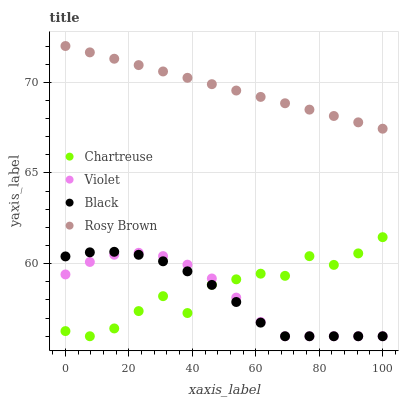Does Black have the minimum area under the curve?
Answer yes or no. Yes. Does Rosy Brown have the maximum area under the curve?
Answer yes or no. Yes. Does Rosy Brown have the minimum area under the curve?
Answer yes or no. No. Does Black have the maximum area under the curve?
Answer yes or no. No. Is Rosy Brown the smoothest?
Answer yes or no. Yes. Is Chartreuse the roughest?
Answer yes or no. Yes. Is Black the smoothest?
Answer yes or no. No. Is Black the roughest?
Answer yes or no. No. Does Chartreuse have the lowest value?
Answer yes or no. Yes. Does Rosy Brown have the lowest value?
Answer yes or no. No. Does Rosy Brown have the highest value?
Answer yes or no. Yes. Does Black have the highest value?
Answer yes or no. No. Is Chartreuse less than Rosy Brown?
Answer yes or no. Yes. Is Rosy Brown greater than Violet?
Answer yes or no. Yes. Does Violet intersect Chartreuse?
Answer yes or no. Yes. Is Violet less than Chartreuse?
Answer yes or no. No. Is Violet greater than Chartreuse?
Answer yes or no. No. Does Chartreuse intersect Rosy Brown?
Answer yes or no. No. 